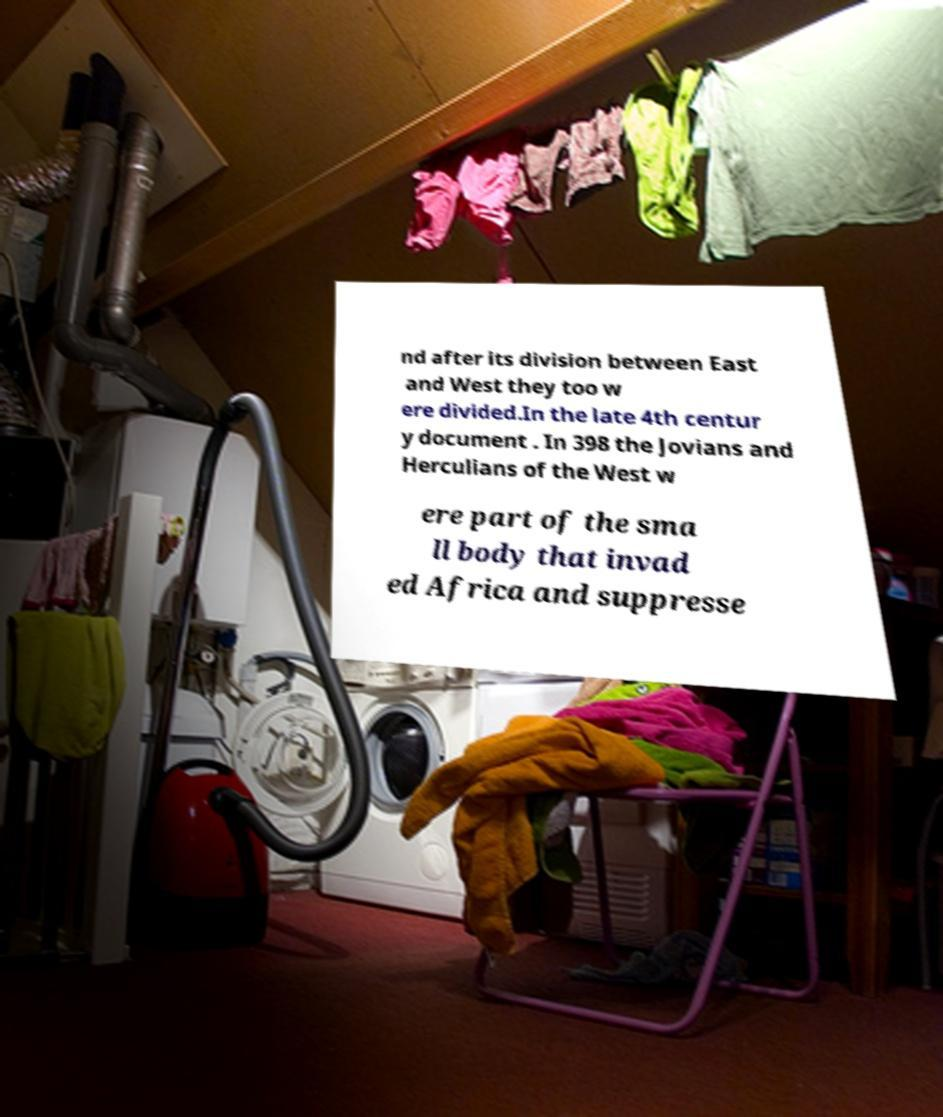Can you read and provide the text displayed in the image?This photo seems to have some interesting text. Can you extract and type it out for me? nd after its division between East and West they too w ere divided.In the late 4th centur y document . In 398 the Jovians and Herculians of the West w ere part of the sma ll body that invad ed Africa and suppresse 